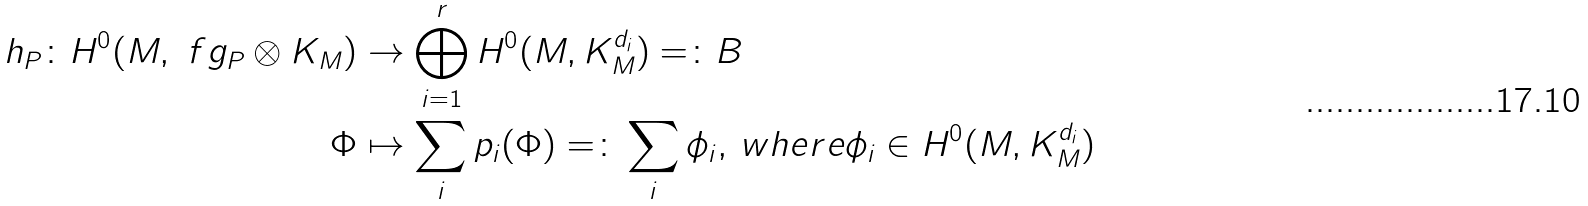<formula> <loc_0><loc_0><loc_500><loc_500>h _ { P } \colon H ^ { 0 } ( M , \ f g _ { P } \otimes K _ { M } ) & \rightarrow \bigoplus _ { i = 1 } ^ { r } H ^ { 0 } ( M , K _ { M } ^ { d _ { i } } ) = \colon B \\ \Phi & \mapsto \sum _ { i } p _ { i } ( \Phi ) = \colon \sum _ { i } \phi _ { i } , \, w h e r e \phi _ { i } \in H ^ { 0 } ( M , K _ { M } ^ { d _ { i } } )</formula> 